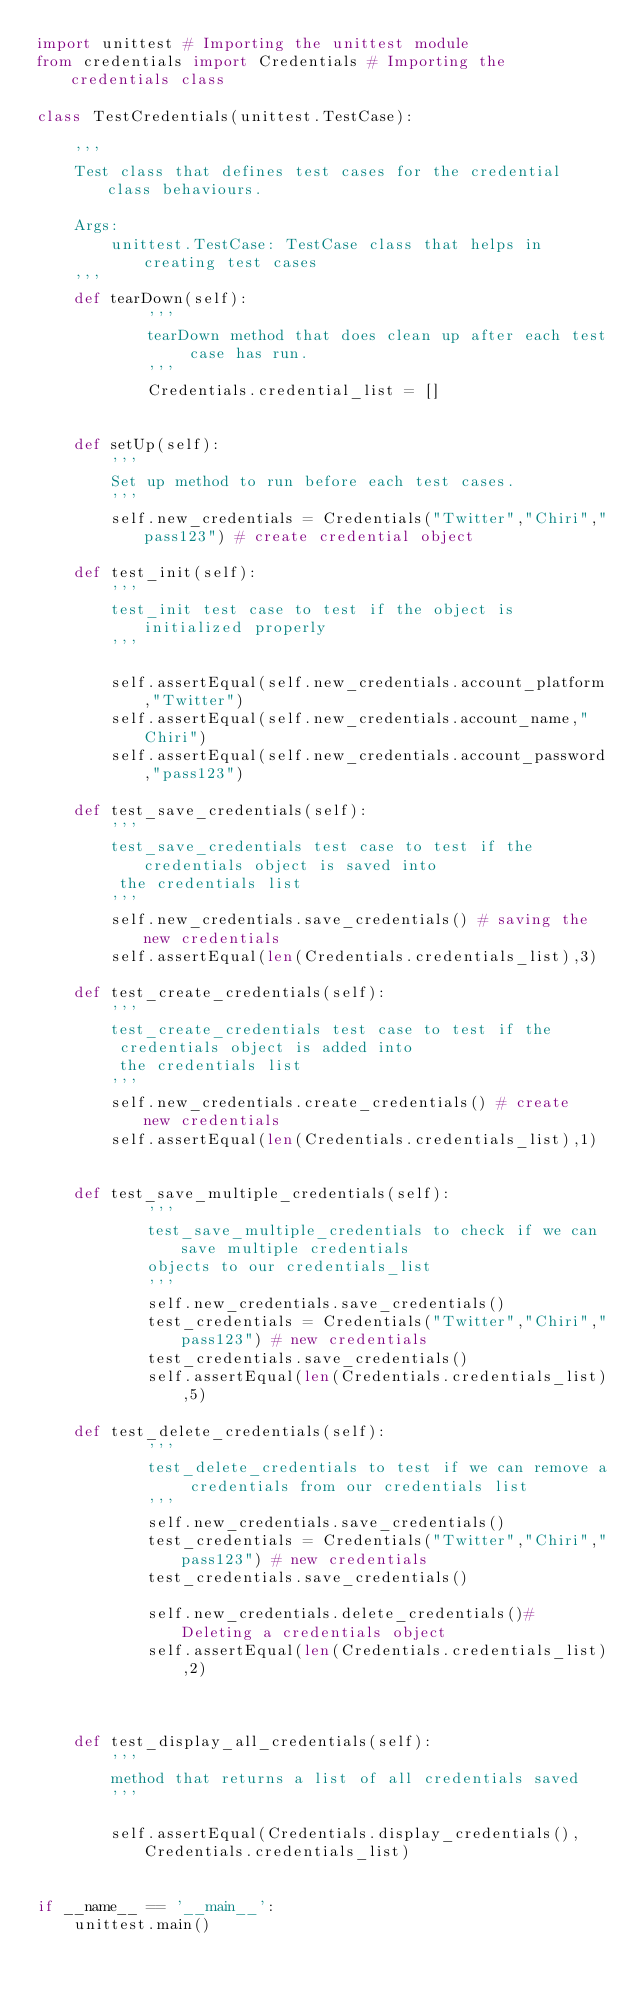<code> <loc_0><loc_0><loc_500><loc_500><_Python_>import unittest # Importing the unittest module
from credentials import Credentials # Importing the credentials class

class TestCredentials(unittest.TestCase):

    '''
    Test class that defines test cases for the credential class behaviours.

    Args:
        unittest.TestCase: TestCase class that helps in creating test cases
    '''
    def tearDown(self):
            '''
            tearDown method that does clean up after each test case has run.
            '''
            Credentials.credential_list = []


    def setUp(self):
        '''
        Set up method to run before each test cases.
        '''
        self.new_credentials = Credentials("Twitter","Chiri","pass123") # create credential object
    
    def test_init(self):
        '''
        test_init test case to test if the object is initialized properly
        '''

        self.assertEqual(self.new_credentials.account_platform,"Twitter")
        self.assertEqual(self.new_credentials.account_name,"Chiri")
        self.assertEqual(self.new_credentials.account_password,"pass123")

    def test_save_credentials(self):
        '''
        test_save_credentials test case to test if the credentials object is saved into
         the credentials list
        '''
        self.new_credentials.save_credentials() # saving the new credentials
        self.assertEqual(len(Credentials.credentials_list),3)
     
    def test_create_credentials(self):
        '''
        test_create_credentials test case to test if the
         credentials object is added into
         the credentials list
        '''
        self.new_credentials.create_credentials() # create  new credentials
        self.assertEqual(len(Credentials.credentials_list),1)
    

    def test_save_multiple_credentials(self):
            '''
            test_save_multiple_credentials to check if we can save multiple credentials
            objects to our credentials_list
            '''
            self.new_credentials.save_credentials()
            test_credentials = Credentials("Twitter","Chiri","pass123") # new credentials
            test_credentials.save_credentials()
            self.assertEqual(len(Credentials.credentials_list),5)

    def test_delete_credentials(self):
            '''
            test_delete_credentials to test if we can remove a credentials from our credentials list
            '''
            self.new_credentials.save_credentials()
            test_credentials = Credentials("Twitter","Chiri","pass123") # new credentials
            test_credentials.save_credentials()

            self.new_credentials.delete_credentials()# Deleting a credentials object
            self.assertEqual(len(Credentials.credentials_list),2)



    def test_display_all_credentials(self):
        '''
        method that returns a list of all credentials saved
        '''

        self.assertEqual(Credentials.display_credentials(),Credentials.credentials_list)
    
   
if __name__ == '__main__':
    unittest.main()    
</code> 